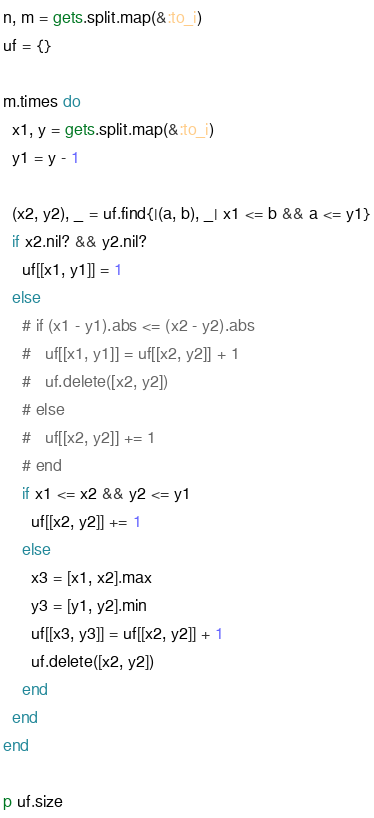<code> <loc_0><loc_0><loc_500><loc_500><_Ruby_>n, m = gets.split.map(&:to_i)
uf = {}

m.times do
  x1, y = gets.split.map(&:to_i)
  y1 = y - 1

  (x2, y2), _ = uf.find{|(a, b), _| x1 <= b && a <= y1}
  if x2.nil? && y2.nil?
    uf[[x1, y1]] = 1
  else
    # if (x1 - y1).abs <= (x2 - y2).abs
    #   uf[[x1, y1]] = uf[[x2, y2]] + 1
    #   uf.delete([x2, y2])
    # else
    #   uf[[x2, y2]] += 1
    # end
    if x1 <= x2 && y2 <= y1
      uf[[x2, y2]] += 1
    else
      x3 = [x1, x2].max
      y3 = [y1, y2].min
      uf[[x3, y3]] = uf[[x2, y2]] + 1
      uf.delete([x2, y2])
    end
  end
end

p uf.size</code> 